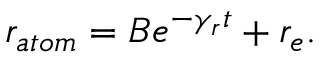<formula> <loc_0><loc_0><loc_500><loc_500>r _ { a t o m } = B e ^ { - \gamma _ { r } t } + r _ { e } .</formula> 